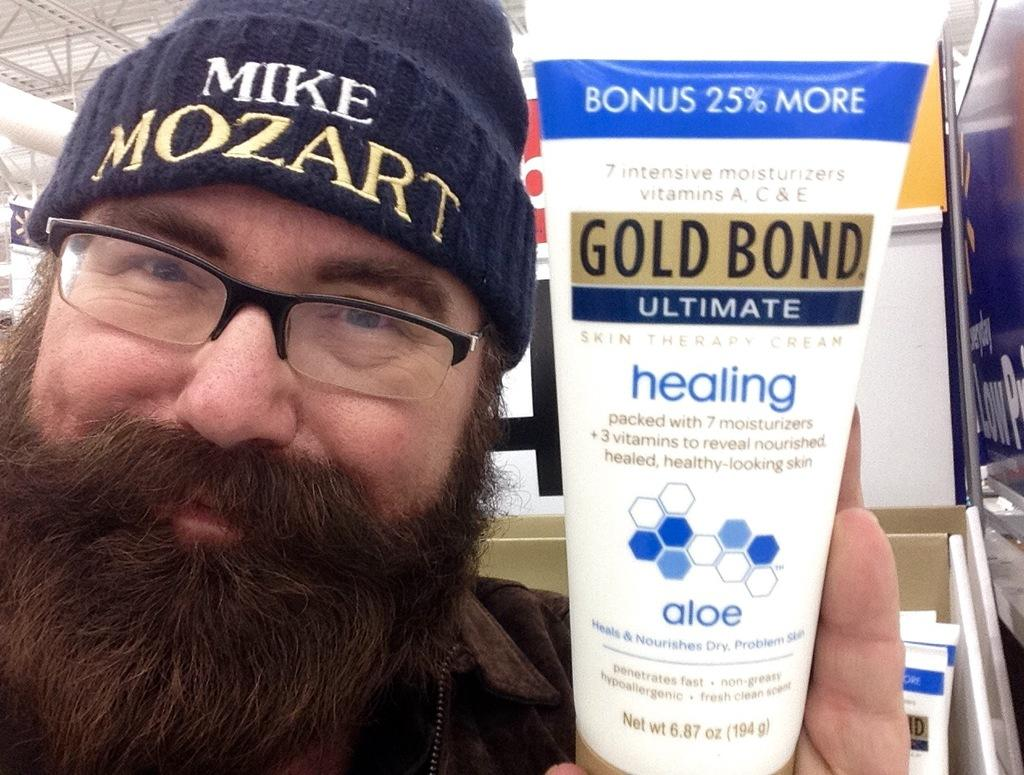Provide a one-sentence caption for the provided image. a man holding a squeeze tube that is labeled 'gold bond ultimate'. 